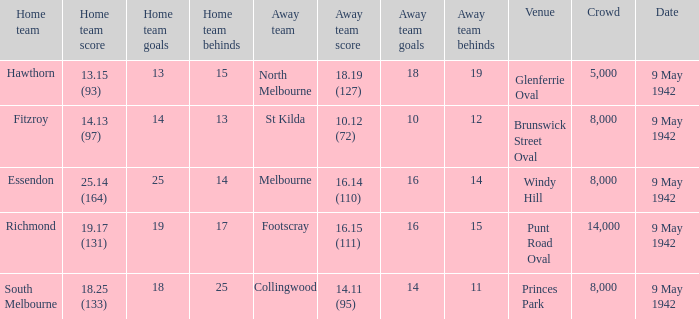How large was the crowd with a home team score of 18.25 (133)? 8000.0. 